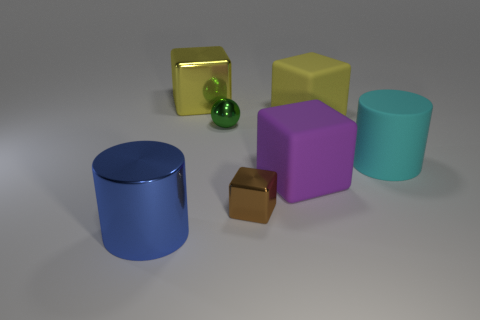Add 3 brown metal blocks. How many objects exist? 10 Subtract all cubes. How many objects are left? 3 Add 5 rubber objects. How many rubber objects exist? 8 Subtract 1 cyan cylinders. How many objects are left? 6 Subtract all small balls. Subtract all large purple objects. How many objects are left? 5 Add 5 large cyan objects. How many large cyan objects are left? 6 